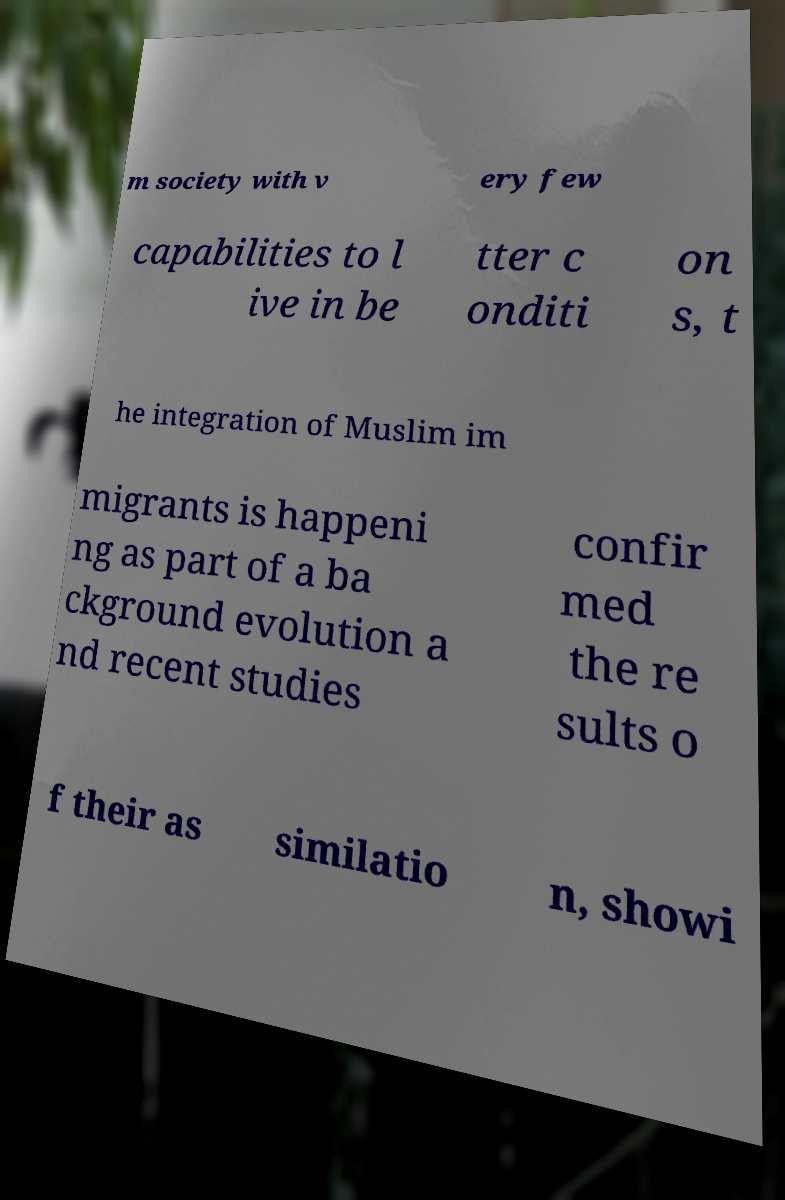Could you extract and type out the text from this image? m society with v ery few capabilities to l ive in be tter c onditi on s, t he integration of Muslim im migrants is happeni ng as part of a ba ckground evolution a nd recent studies confir med the re sults o f their as similatio n, showi 